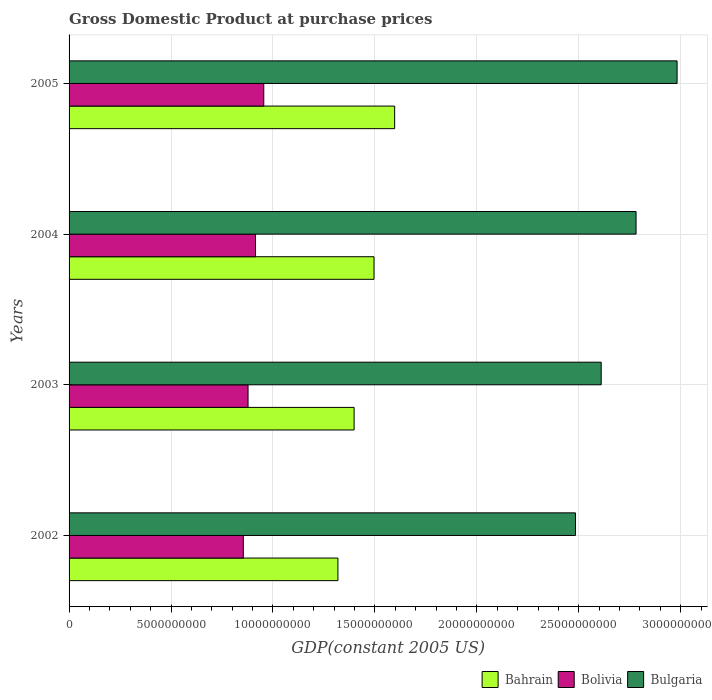How many different coloured bars are there?
Your answer should be compact. 3. Are the number of bars per tick equal to the number of legend labels?
Your answer should be compact. Yes. Are the number of bars on each tick of the Y-axis equal?
Your answer should be compact. Yes. What is the GDP at purchase prices in Bahrain in 2002?
Give a very brief answer. 1.32e+1. Across all years, what is the maximum GDP at purchase prices in Bolivia?
Offer a very short reply. 9.55e+09. Across all years, what is the minimum GDP at purchase prices in Bahrain?
Offer a terse response. 1.32e+1. In which year was the GDP at purchase prices in Bahrain minimum?
Offer a very short reply. 2002. What is the total GDP at purchase prices in Bulgaria in the graph?
Make the answer very short. 1.09e+11. What is the difference between the GDP at purchase prices in Bolivia in 2003 and that in 2005?
Your response must be concise. -7.71e+08. What is the difference between the GDP at purchase prices in Bulgaria in 2005 and the GDP at purchase prices in Bahrain in 2002?
Give a very brief answer. 1.66e+1. What is the average GDP at purchase prices in Bolivia per year?
Offer a terse response. 9.00e+09. In the year 2005, what is the difference between the GDP at purchase prices in Bulgaria and GDP at purchase prices in Bahrain?
Offer a terse response. 1.39e+1. In how many years, is the GDP at purchase prices in Bahrain greater than 4000000000 US$?
Make the answer very short. 4. What is the ratio of the GDP at purchase prices in Bulgaria in 2003 to that in 2005?
Your answer should be very brief. 0.88. Is the difference between the GDP at purchase prices in Bulgaria in 2002 and 2004 greater than the difference between the GDP at purchase prices in Bahrain in 2002 and 2004?
Offer a very short reply. No. What is the difference between the highest and the second highest GDP at purchase prices in Bahrain?
Your answer should be very brief. 1.01e+09. What is the difference between the highest and the lowest GDP at purchase prices in Bulgaria?
Your answer should be compact. 4.98e+09. Is the sum of the GDP at purchase prices in Bahrain in 2004 and 2005 greater than the maximum GDP at purchase prices in Bulgaria across all years?
Your answer should be very brief. Yes. What does the 1st bar from the bottom in 2003 represents?
Offer a very short reply. Bahrain. How many bars are there?
Make the answer very short. 12. Does the graph contain any zero values?
Offer a very short reply. No. Does the graph contain grids?
Provide a succinct answer. Yes. Where does the legend appear in the graph?
Offer a terse response. Bottom right. What is the title of the graph?
Give a very brief answer. Gross Domestic Product at purchase prices. What is the label or title of the X-axis?
Keep it short and to the point. GDP(constant 2005 US). What is the GDP(constant 2005 US) in Bahrain in 2002?
Keep it short and to the point. 1.32e+1. What is the GDP(constant 2005 US) in Bolivia in 2002?
Ensure brevity in your answer.  8.55e+09. What is the GDP(constant 2005 US) of Bulgaria in 2002?
Give a very brief answer. 2.48e+1. What is the GDP(constant 2005 US) in Bahrain in 2003?
Provide a short and direct response. 1.40e+1. What is the GDP(constant 2005 US) of Bolivia in 2003?
Ensure brevity in your answer.  8.78e+09. What is the GDP(constant 2005 US) in Bulgaria in 2003?
Your answer should be compact. 2.61e+1. What is the GDP(constant 2005 US) in Bahrain in 2004?
Make the answer very short. 1.50e+1. What is the GDP(constant 2005 US) in Bolivia in 2004?
Give a very brief answer. 9.14e+09. What is the GDP(constant 2005 US) in Bulgaria in 2004?
Your answer should be very brief. 2.78e+1. What is the GDP(constant 2005 US) in Bahrain in 2005?
Ensure brevity in your answer.  1.60e+1. What is the GDP(constant 2005 US) of Bolivia in 2005?
Your response must be concise. 9.55e+09. What is the GDP(constant 2005 US) in Bulgaria in 2005?
Provide a short and direct response. 2.98e+1. Across all years, what is the maximum GDP(constant 2005 US) of Bahrain?
Ensure brevity in your answer.  1.60e+1. Across all years, what is the maximum GDP(constant 2005 US) of Bolivia?
Your response must be concise. 9.55e+09. Across all years, what is the maximum GDP(constant 2005 US) of Bulgaria?
Your answer should be compact. 2.98e+1. Across all years, what is the minimum GDP(constant 2005 US) in Bahrain?
Offer a very short reply. 1.32e+1. Across all years, what is the minimum GDP(constant 2005 US) in Bolivia?
Your answer should be very brief. 8.55e+09. Across all years, what is the minimum GDP(constant 2005 US) of Bulgaria?
Keep it short and to the point. 2.48e+1. What is the total GDP(constant 2005 US) of Bahrain in the graph?
Make the answer very short. 5.81e+1. What is the total GDP(constant 2005 US) of Bolivia in the graph?
Make the answer very short. 3.60e+1. What is the total GDP(constant 2005 US) in Bulgaria in the graph?
Your answer should be very brief. 1.09e+11. What is the difference between the GDP(constant 2005 US) of Bahrain in 2002 and that in 2003?
Keep it short and to the point. -7.94e+08. What is the difference between the GDP(constant 2005 US) of Bolivia in 2002 and that in 2003?
Offer a terse response. -2.32e+08. What is the difference between the GDP(constant 2005 US) in Bulgaria in 2002 and that in 2003?
Provide a short and direct response. -1.26e+09. What is the difference between the GDP(constant 2005 US) in Bahrain in 2002 and that in 2004?
Provide a succinct answer. -1.77e+09. What is the difference between the GDP(constant 2005 US) in Bolivia in 2002 and that in 2004?
Keep it short and to the point. -5.98e+08. What is the difference between the GDP(constant 2005 US) of Bulgaria in 2002 and that in 2004?
Your answer should be very brief. -2.97e+09. What is the difference between the GDP(constant 2005 US) of Bahrain in 2002 and that in 2005?
Make the answer very short. -2.78e+09. What is the difference between the GDP(constant 2005 US) of Bolivia in 2002 and that in 2005?
Provide a succinct answer. -1.00e+09. What is the difference between the GDP(constant 2005 US) in Bulgaria in 2002 and that in 2005?
Give a very brief answer. -4.98e+09. What is the difference between the GDP(constant 2005 US) of Bahrain in 2003 and that in 2004?
Your answer should be very brief. -9.76e+08. What is the difference between the GDP(constant 2005 US) in Bolivia in 2003 and that in 2004?
Provide a short and direct response. -3.66e+08. What is the difference between the GDP(constant 2005 US) in Bulgaria in 2003 and that in 2004?
Your response must be concise. -1.71e+09. What is the difference between the GDP(constant 2005 US) of Bahrain in 2003 and that in 2005?
Offer a very short reply. -1.99e+09. What is the difference between the GDP(constant 2005 US) of Bolivia in 2003 and that in 2005?
Your answer should be very brief. -7.71e+08. What is the difference between the GDP(constant 2005 US) of Bulgaria in 2003 and that in 2005?
Provide a succinct answer. -3.72e+09. What is the difference between the GDP(constant 2005 US) in Bahrain in 2004 and that in 2005?
Offer a very short reply. -1.01e+09. What is the difference between the GDP(constant 2005 US) in Bolivia in 2004 and that in 2005?
Provide a succinct answer. -4.04e+08. What is the difference between the GDP(constant 2005 US) of Bulgaria in 2004 and that in 2005?
Your answer should be compact. -2.01e+09. What is the difference between the GDP(constant 2005 US) in Bahrain in 2002 and the GDP(constant 2005 US) in Bolivia in 2003?
Your answer should be very brief. 4.41e+09. What is the difference between the GDP(constant 2005 US) of Bahrain in 2002 and the GDP(constant 2005 US) of Bulgaria in 2003?
Offer a terse response. -1.29e+1. What is the difference between the GDP(constant 2005 US) of Bolivia in 2002 and the GDP(constant 2005 US) of Bulgaria in 2003?
Ensure brevity in your answer.  -1.76e+1. What is the difference between the GDP(constant 2005 US) of Bahrain in 2002 and the GDP(constant 2005 US) of Bolivia in 2004?
Your answer should be compact. 4.04e+09. What is the difference between the GDP(constant 2005 US) in Bahrain in 2002 and the GDP(constant 2005 US) in Bulgaria in 2004?
Offer a very short reply. -1.46e+1. What is the difference between the GDP(constant 2005 US) of Bolivia in 2002 and the GDP(constant 2005 US) of Bulgaria in 2004?
Provide a short and direct response. -1.93e+1. What is the difference between the GDP(constant 2005 US) in Bahrain in 2002 and the GDP(constant 2005 US) in Bolivia in 2005?
Your response must be concise. 3.64e+09. What is the difference between the GDP(constant 2005 US) of Bahrain in 2002 and the GDP(constant 2005 US) of Bulgaria in 2005?
Provide a succinct answer. -1.66e+1. What is the difference between the GDP(constant 2005 US) of Bolivia in 2002 and the GDP(constant 2005 US) of Bulgaria in 2005?
Your answer should be compact. -2.13e+1. What is the difference between the GDP(constant 2005 US) in Bahrain in 2003 and the GDP(constant 2005 US) in Bolivia in 2004?
Keep it short and to the point. 4.84e+09. What is the difference between the GDP(constant 2005 US) of Bahrain in 2003 and the GDP(constant 2005 US) of Bulgaria in 2004?
Keep it short and to the point. -1.38e+1. What is the difference between the GDP(constant 2005 US) of Bolivia in 2003 and the GDP(constant 2005 US) of Bulgaria in 2004?
Make the answer very short. -1.90e+1. What is the difference between the GDP(constant 2005 US) of Bahrain in 2003 and the GDP(constant 2005 US) of Bolivia in 2005?
Your answer should be very brief. 4.43e+09. What is the difference between the GDP(constant 2005 US) of Bahrain in 2003 and the GDP(constant 2005 US) of Bulgaria in 2005?
Ensure brevity in your answer.  -1.58e+1. What is the difference between the GDP(constant 2005 US) of Bolivia in 2003 and the GDP(constant 2005 US) of Bulgaria in 2005?
Your response must be concise. -2.10e+1. What is the difference between the GDP(constant 2005 US) of Bahrain in 2004 and the GDP(constant 2005 US) of Bolivia in 2005?
Your answer should be compact. 5.41e+09. What is the difference between the GDP(constant 2005 US) of Bahrain in 2004 and the GDP(constant 2005 US) of Bulgaria in 2005?
Ensure brevity in your answer.  -1.49e+1. What is the difference between the GDP(constant 2005 US) in Bolivia in 2004 and the GDP(constant 2005 US) in Bulgaria in 2005?
Give a very brief answer. -2.07e+1. What is the average GDP(constant 2005 US) of Bahrain per year?
Provide a short and direct response. 1.45e+1. What is the average GDP(constant 2005 US) of Bolivia per year?
Offer a terse response. 9.00e+09. What is the average GDP(constant 2005 US) in Bulgaria per year?
Your response must be concise. 2.71e+1. In the year 2002, what is the difference between the GDP(constant 2005 US) in Bahrain and GDP(constant 2005 US) in Bolivia?
Your answer should be compact. 4.64e+09. In the year 2002, what is the difference between the GDP(constant 2005 US) of Bahrain and GDP(constant 2005 US) of Bulgaria?
Your answer should be compact. -1.17e+1. In the year 2002, what is the difference between the GDP(constant 2005 US) of Bolivia and GDP(constant 2005 US) of Bulgaria?
Offer a very short reply. -1.63e+1. In the year 2003, what is the difference between the GDP(constant 2005 US) in Bahrain and GDP(constant 2005 US) in Bolivia?
Make the answer very short. 5.20e+09. In the year 2003, what is the difference between the GDP(constant 2005 US) of Bahrain and GDP(constant 2005 US) of Bulgaria?
Make the answer very short. -1.21e+1. In the year 2003, what is the difference between the GDP(constant 2005 US) of Bolivia and GDP(constant 2005 US) of Bulgaria?
Your answer should be very brief. -1.73e+1. In the year 2004, what is the difference between the GDP(constant 2005 US) in Bahrain and GDP(constant 2005 US) in Bolivia?
Your answer should be compact. 5.81e+09. In the year 2004, what is the difference between the GDP(constant 2005 US) of Bahrain and GDP(constant 2005 US) of Bulgaria?
Your answer should be very brief. -1.29e+1. In the year 2004, what is the difference between the GDP(constant 2005 US) of Bolivia and GDP(constant 2005 US) of Bulgaria?
Your answer should be very brief. -1.87e+1. In the year 2005, what is the difference between the GDP(constant 2005 US) of Bahrain and GDP(constant 2005 US) of Bolivia?
Your response must be concise. 6.42e+09. In the year 2005, what is the difference between the GDP(constant 2005 US) of Bahrain and GDP(constant 2005 US) of Bulgaria?
Offer a very short reply. -1.39e+1. In the year 2005, what is the difference between the GDP(constant 2005 US) of Bolivia and GDP(constant 2005 US) of Bulgaria?
Provide a succinct answer. -2.03e+1. What is the ratio of the GDP(constant 2005 US) of Bahrain in 2002 to that in 2003?
Provide a short and direct response. 0.94. What is the ratio of the GDP(constant 2005 US) in Bolivia in 2002 to that in 2003?
Keep it short and to the point. 0.97. What is the ratio of the GDP(constant 2005 US) of Bulgaria in 2002 to that in 2003?
Offer a very short reply. 0.95. What is the ratio of the GDP(constant 2005 US) of Bahrain in 2002 to that in 2004?
Provide a short and direct response. 0.88. What is the ratio of the GDP(constant 2005 US) in Bolivia in 2002 to that in 2004?
Your answer should be compact. 0.93. What is the ratio of the GDP(constant 2005 US) of Bulgaria in 2002 to that in 2004?
Your response must be concise. 0.89. What is the ratio of the GDP(constant 2005 US) of Bahrain in 2002 to that in 2005?
Provide a succinct answer. 0.83. What is the ratio of the GDP(constant 2005 US) in Bolivia in 2002 to that in 2005?
Offer a terse response. 0.9. What is the ratio of the GDP(constant 2005 US) of Bulgaria in 2002 to that in 2005?
Your answer should be compact. 0.83. What is the ratio of the GDP(constant 2005 US) in Bahrain in 2003 to that in 2004?
Offer a terse response. 0.93. What is the ratio of the GDP(constant 2005 US) in Bolivia in 2003 to that in 2004?
Keep it short and to the point. 0.96. What is the ratio of the GDP(constant 2005 US) of Bulgaria in 2003 to that in 2004?
Your answer should be compact. 0.94. What is the ratio of the GDP(constant 2005 US) of Bahrain in 2003 to that in 2005?
Your answer should be compact. 0.88. What is the ratio of the GDP(constant 2005 US) of Bolivia in 2003 to that in 2005?
Provide a short and direct response. 0.92. What is the ratio of the GDP(constant 2005 US) of Bulgaria in 2003 to that in 2005?
Your response must be concise. 0.88. What is the ratio of the GDP(constant 2005 US) in Bahrain in 2004 to that in 2005?
Make the answer very short. 0.94. What is the ratio of the GDP(constant 2005 US) in Bolivia in 2004 to that in 2005?
Your answer should be compact. 0.96. What is the ratio of the GDP(constant 2005 US) in Bulgaria in 2004 to that in 2005?
Your answer should be very brief. 0.93. What is the difference between the highest and the second highest GDP(constant 2005 US) in Bahrain?
Ensure brevity in your answer.  1.01e+09. What is the difference between the highest and the second highest GDP(constant 2005 US) of Bolivia?
Offer a very short reply. 4.04e+08. What is the difference between the highest and the second highest GDP(constant 2005 US) in Bulgaria?
Your response must be concise. 2.01e+09. What is the difference between the highest and the lowest GDP(constant 2005 US) in Bahrain?
Give a very brief answer. 2.78e+09. What is the difference between the highest and the lowest GDP(constant 2005 US) of Bolivia?
Give a very brief answer. 1.00e+09. What is the difference between the highest and the lowest GDP(constant 2005 US) of Bulgaria?
Give a very brief answer. 4.98e+09. 